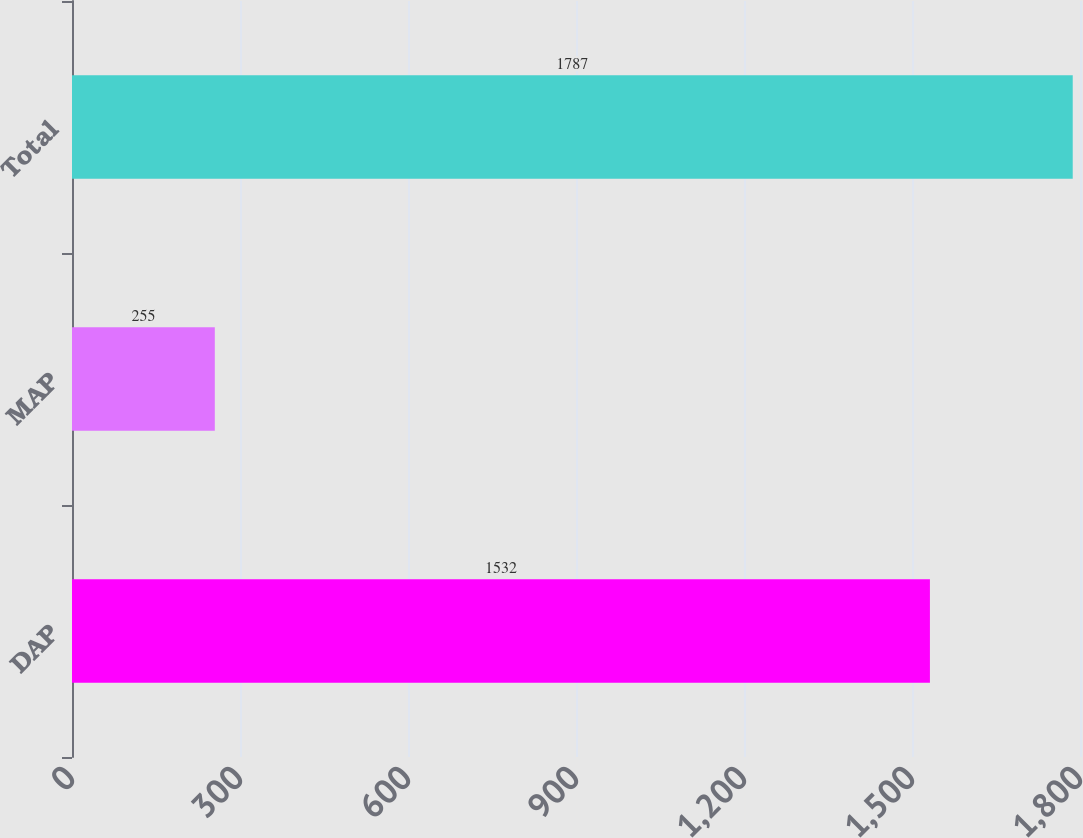<chart> <loc_0><loc_0><loc_500><loc_500><bar_chart><fcel>DAP<fcel>MAP<fcel>Total<nl><fcel>1532<fcel>255<fcel>1787<nl></chart> 